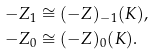<formula> <loc_0><loc_0><loc_500><loc_500>- Z _ { 1 } & \cong ( - Z ) _ { - 1 } ( K ) , \\ - Z _ { 0 } & \cong ( - Z ) _ { 0 } ( K ) .</formula> 